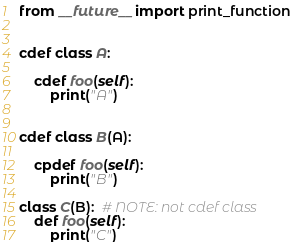<code> <loc_0><loc_0><loc_500><loc_500><_Cython_>from __future__ import print_function


cdef class A:

    cdef foo(self):
        print("A")


cdef class B(A):

    cpdef foo(self):
        print("B")

class C(B):  # NOTE: not cdef class
    def foo(self):
        print("C")
</code> 